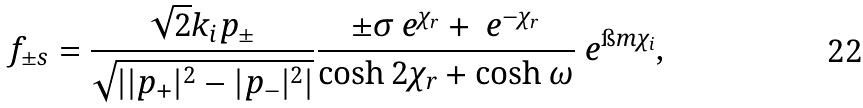<formula> <loc_0><loc_0><loc_500><loc_500>\ f _ { \pm s } = \frac { \sqrt { 2 } k _ { i } p _ { \pm } } { \sqrt { | | p _ { + } | ^ { 2 } - | p _ { - } | ^ { 2 } | } } \frac { \pm \sigma \ e ^ { \chi _ { r } } + \ e ^ { - \chi _ { r } } } { \cosh 2 \chi _ { r } + \cosh \omega } \ e ^ { \i m \chi _ { i } } ,</formula> 